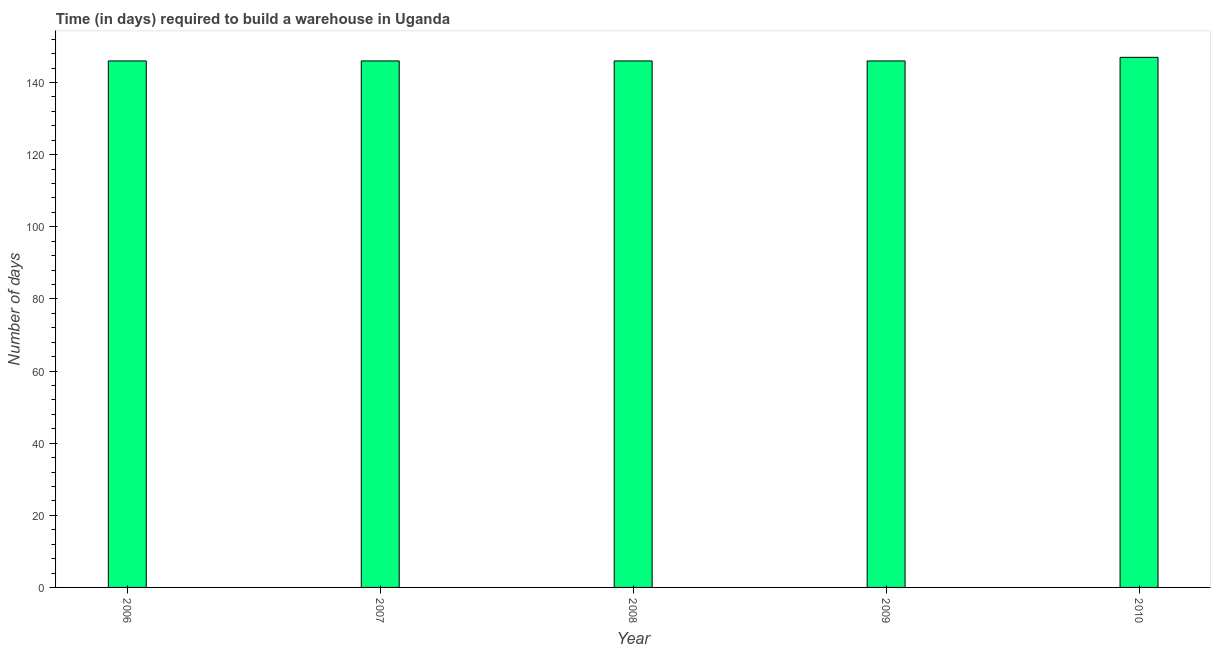What is the title of the graph?
Give a very brief answer. Time (in days) required to build a warehouse in Uganda. What is the label or title of the X-axis?
Offer a very short reply. Year. What is the label or title of the Y-axis?
Your answer should be very brief. Number of days. What is the time required to build a warehouse in 2008?
Give a very brief answer. 146. Across all years, what is the maximum time required to build a warehouse?
Provide a short and direct response. 147. Across all years, what is the minimum time required to build a warehouse?
Provide a short and direct response. 146. In which year was the time required to build a warehouse maximum?
Give a very brief answer. 2010. What is the sum of the time required to build a warehouse?
Your response must be concise. 731. What is the average time required to build a warehouse per year?
Your response must be concise. 146. What is the median time required to build a warehouse?
Provide a succinct answer. 146. Is the time required to build a warehouse in 2007 less than that in 2010?
Your response must be concise. Yes. What is the difference between the highest and the second highest time required to build a warehouse?
Make the answer very short. 1. What is the difference between the highest and the lowest time required to build a warehouse?
Offer a terse response. 1. How many bars are there?
Give a very brief answer. 5. Are all the bars in the graph horizontal?
Your answer should be very brief. No. How many years are there in the graph?
Provide a succinct answer. 5. What is the Number of days in 2006?
Your response must be concise. 146. What is the Number of days in 2007?
Offer a very short reply. 146. What is the Number of days in 2008?
Provide a short and direct response. 146. What is the Number of days in 2009?
Provide a succinct answer. 146. What is the Number of days in 2010?
Your response must be concise. 147. What is the difference between the Number of days in 2006 and 2008?
Provide a succinct answer. 0. What is the difference between the Number of days in 2007 and 2008?
Keep it short and to the point. 0. What is the difference between the Number of days in 2008 and 2009?
Your answer should be very brief. 0. What is the ratio of the Number of days in 2006 to that in 2008?
Your response must be concise. 1. What is the ratio of the Number of days in 2008 to that in 2009?
Your answer should be very brief. 1. What is the ratio of the Number of days in 2009 to that in 2010?
Provide a short and direct response. 0.99. 